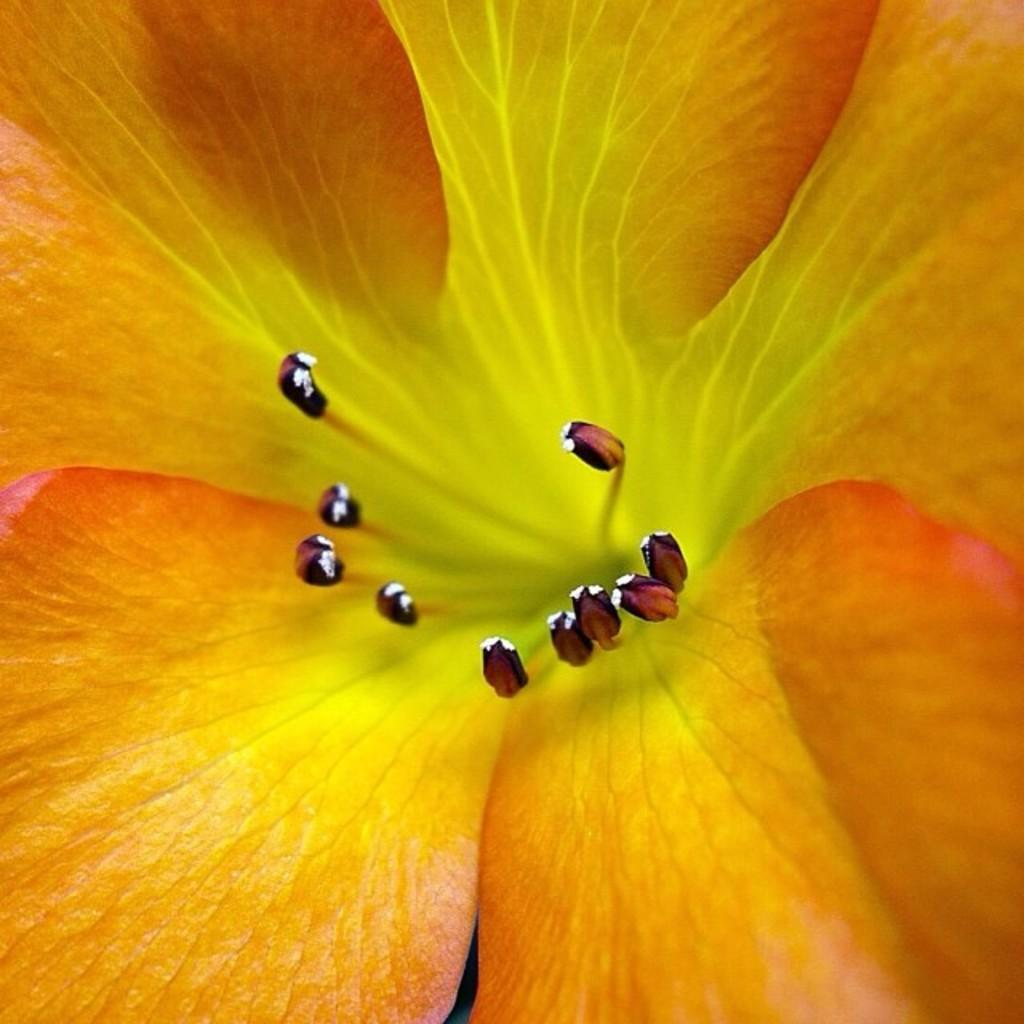What is the main subject of the image? There is a flower in the image. Who is the creator of the flower in the image? The image does not provide information about the creator of the flower. 